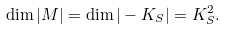Convert formula to latex. <formula><loc_0><loc_0><loc_500><loc_500>\dim | M | = \dim | - K _ { S } | = K _ { S } ^ { 2 } .</formula> 